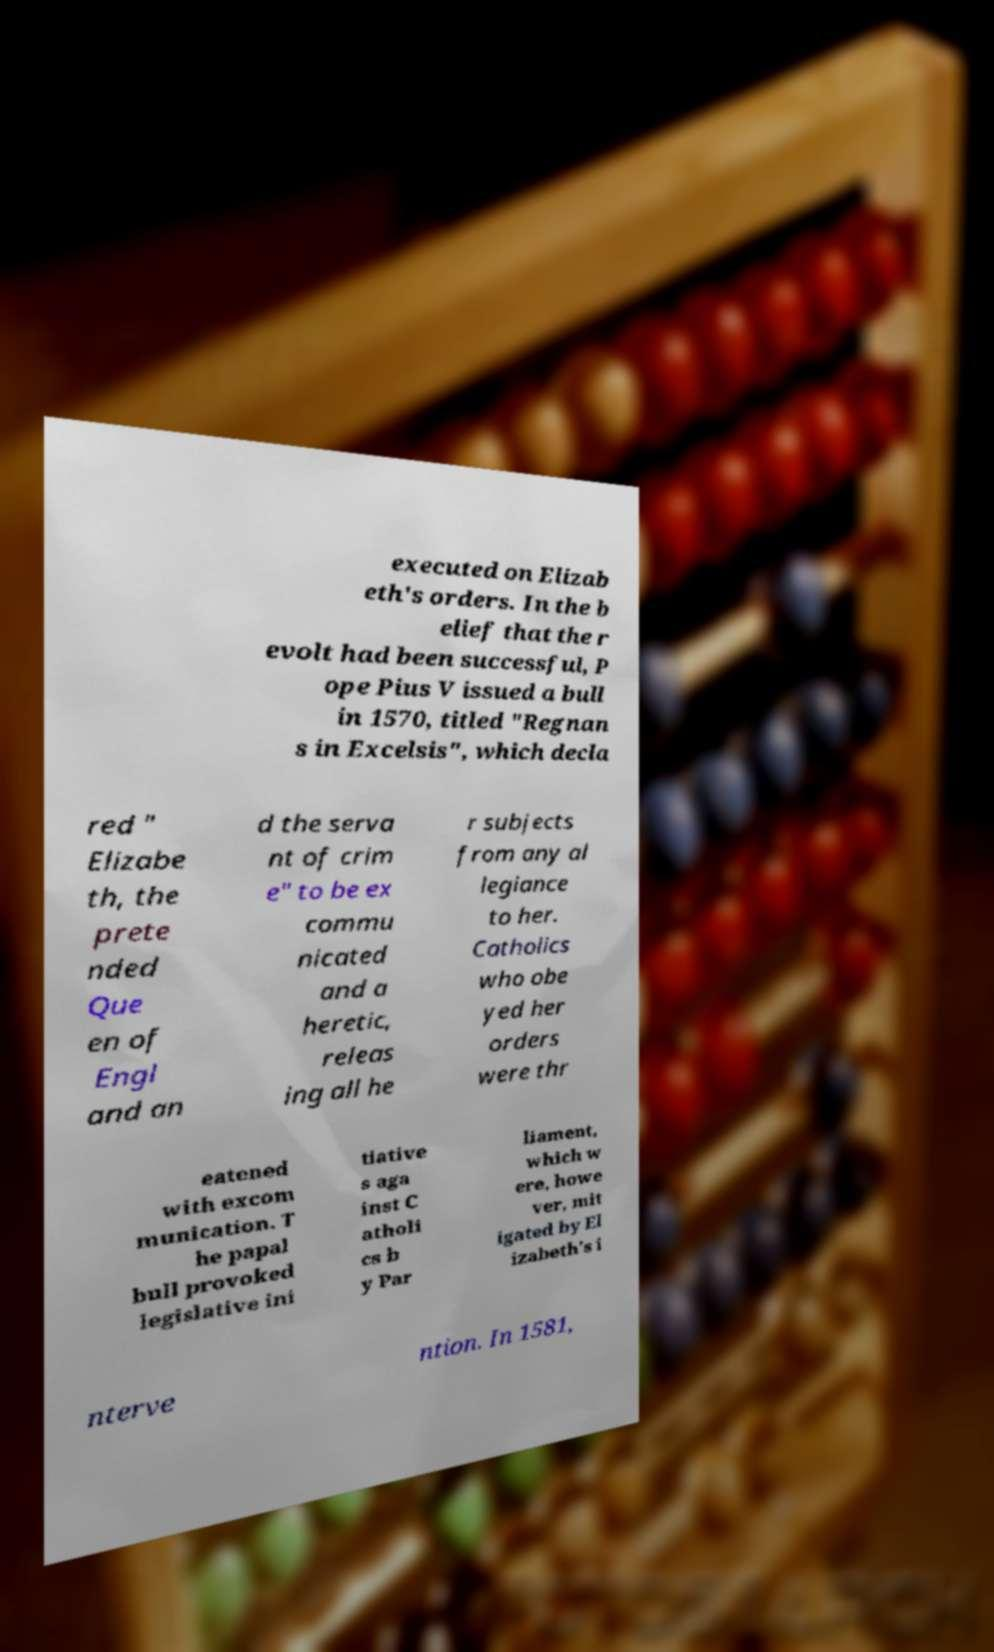Can you accurately transcribe the text from the provided image for me? executed on Elizab eth's orders. In the b elief that the r evolt had been successful, P ope Pius V issued a bull in 1570, titled "Regnan s in Excelsis", which decla red " Elizabe th, the prete nded Que en of Engl and an d the serva nt of crim e" to be ex commu nicated and a heretic, releas ing all he r subjects from any al legiance to her. Catholics who obe yed her orders were thr eatened with excom munication. T he papal bull provoked legislative ini tiative s aga inst C atholi cs b y Par liament, which w ere, howe ver, mit igated by El izabeth's i nterve ntion. In 1581, 